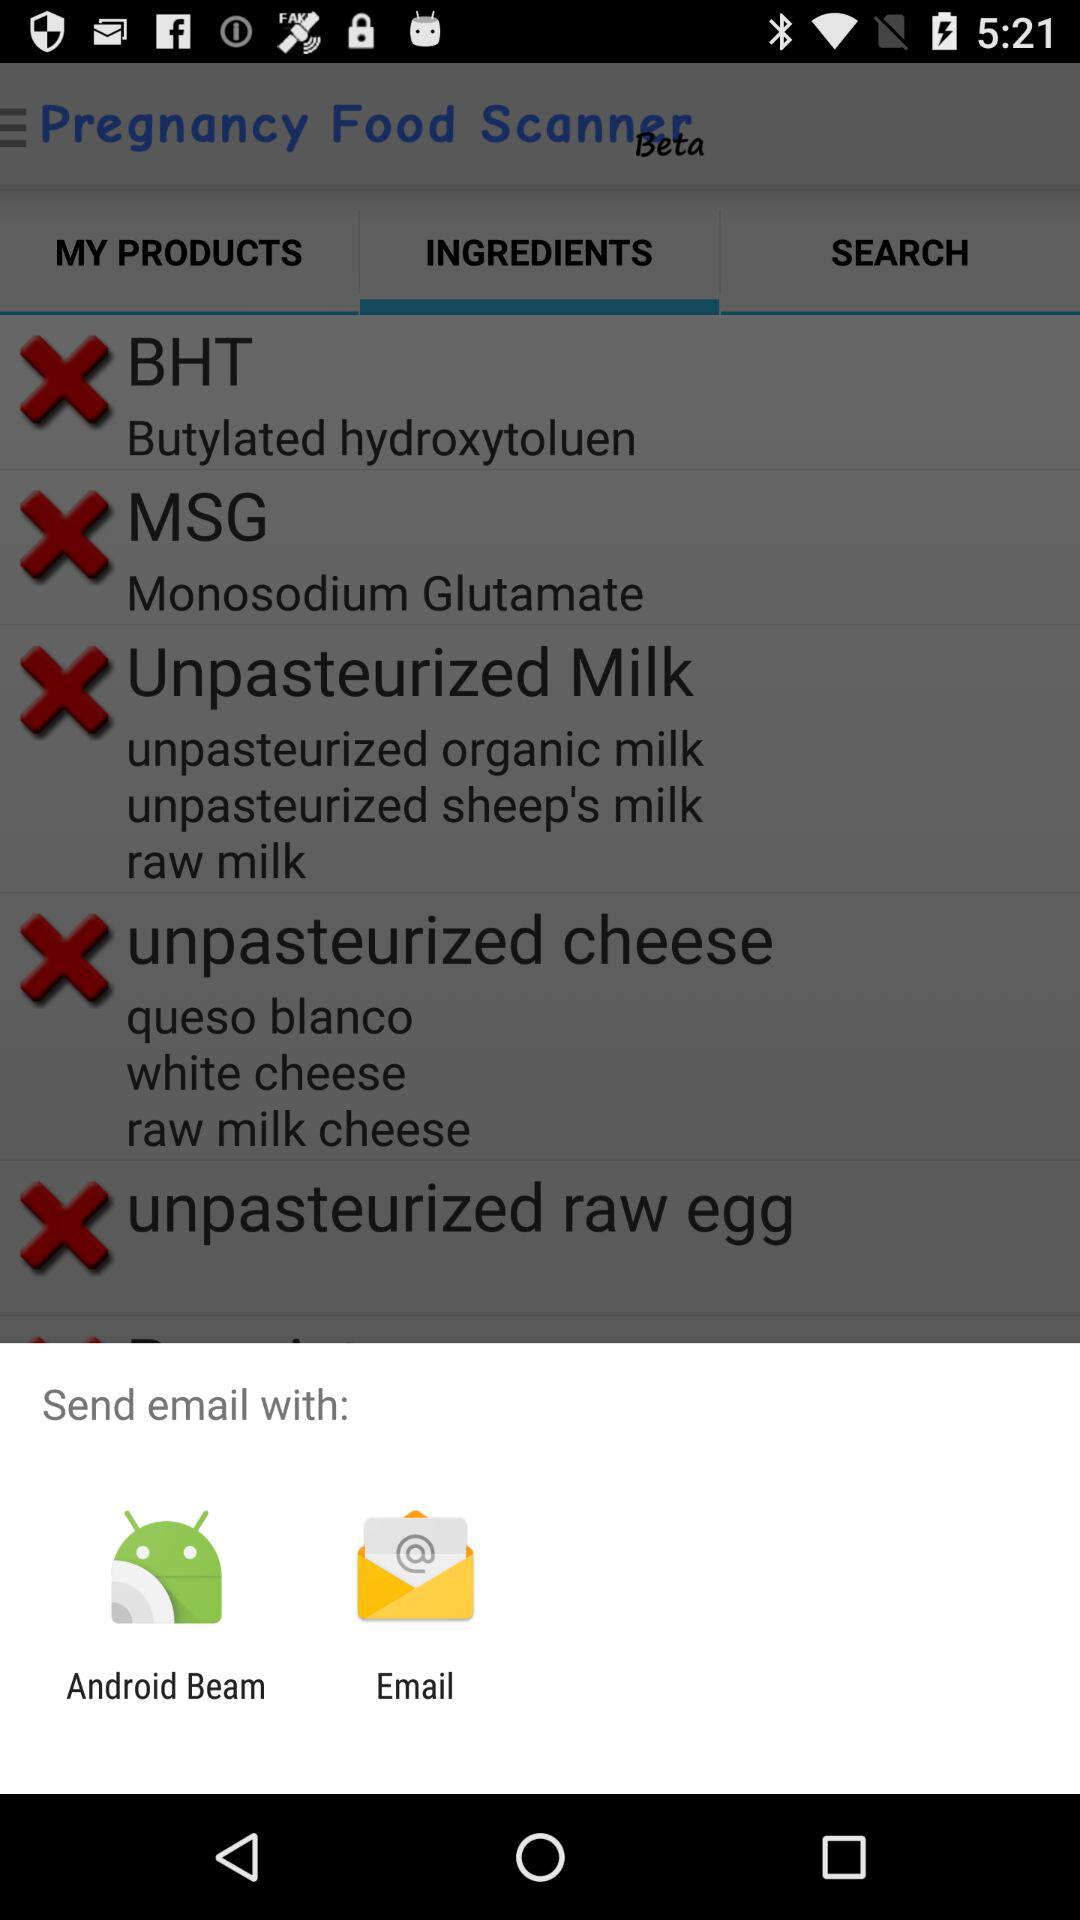How many unpasteurized items are there on the screen?
Answer the question using a single word or phrase. 3 